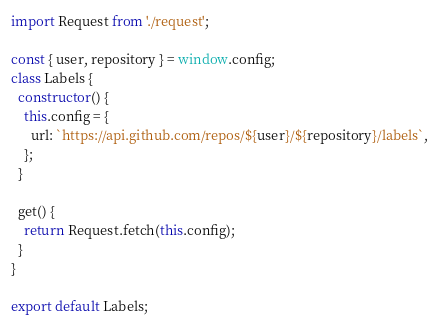Convert code to text. <code><loc_0><loc_0><loc_500><loc_500><_JavaScript_>import Request from './request';

const { user, repository } = window.config;
class Labels {
  constructor() {
    this.config = {
      url: `https://api.github.com/repos/${user}/${repository}/labels`,
    };
  }

  get() {
    return Request.fetch(this.config);
  }
}

export default Labels;
</code> 